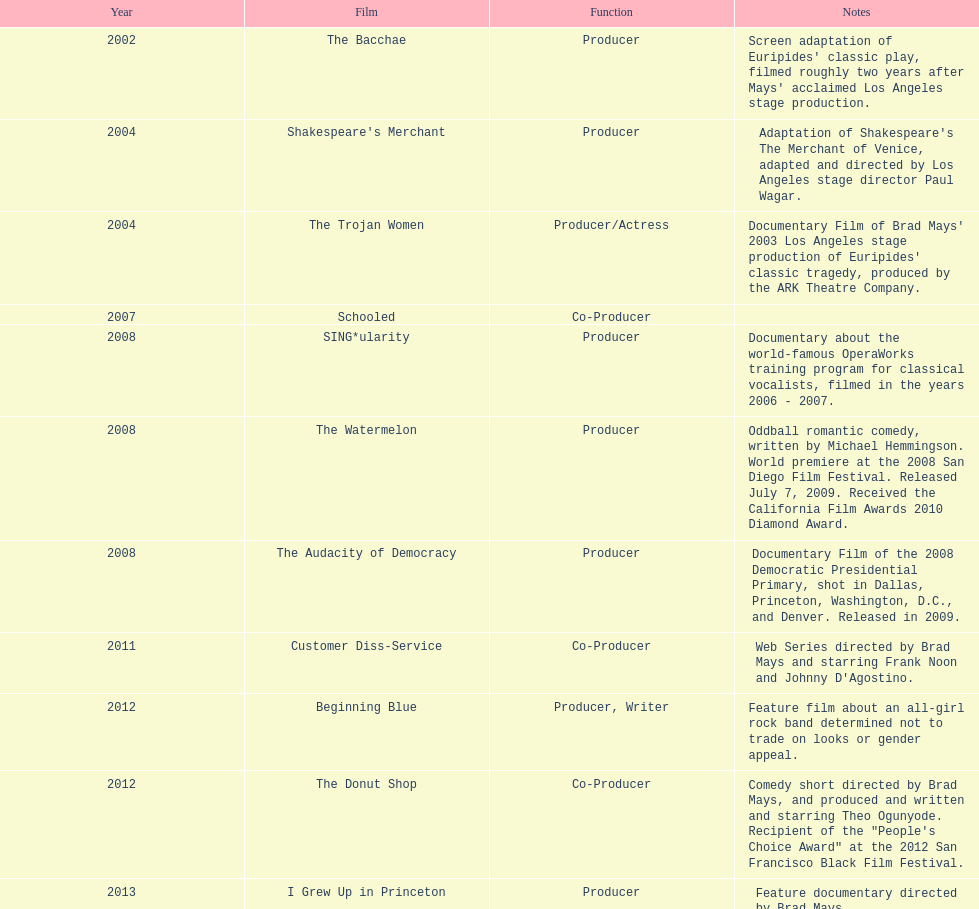During which year did ms. starfelt's film production reach its peak? 2008. Can you give me this table as a dict? {'header': ['Year', 'Film', 'Function', 'Notes'], 'rows': [['2002', 'The Bacchae', 'Producer', "Screen adaptation of Euripides' classic play, filmed roughly two years after Mays' acclaimed Los Angeles stage production."], ['2004', "Shakespeare's Merchant", 'Producer', "Adaptation of Shakespeare's The Merchant of Venice, adapted and directed by Los Angeles stage director Paul Wagar."], ['2004', 'The Trojan Women', 'Producer/Actress', "Documentary Film of Brad Mays' 2003 Los Angeles stage production of Euripides' classic tragedy, produced by the ARK Theatre Company."], ['2007', 'Schooled', 'Co-Producer', ''], ['2008', 'SING*ularity', 'Producer', 'Documentary about the world-famous OperaWorks training program for classical vocalists, filmed in the years 2006 - 2007.'], ['2008', 'The Watermelon', 'Producer', 'Oddball romantic comedy, written by Michael Hemmingson. World premiere at the 2008 San Diego Film Festival. Released July 7, 2009. Received the California Film Awards 2010 Diamond Award.'], ['2008', 'The Audacity of Democracy', 'Producer', 'Documentary Film of the 2008 Democratic Presidential Primary, shot in Dallas, Princeton, Washington, D.C., and Denver. Released in 2009.'], ['2011', 'Customer Diss-Service', 'Co-Producer', "Web Series directed by Brad Mays and starring Frank Noon and Johnny D'Agostino."], ['2012', 'Beginning Blue', 'Producer, Writer', 'Feature film about an all-girl rock band determined not to trade on looks or gender appeal.'], ['2012', 'The Donut Shop', 'Co-Producer', 'Comedy short directed by Brad Mays, and produced and written and starring Theo Ogunyode. Recipient of the "People\'s Choice Award" at the 2012 San Francisco Black Film Festival.'], ['2013', 'I Grew Up in Princeton', 'Producer', 'Feature documentary directed by Brad Mays.']]} 